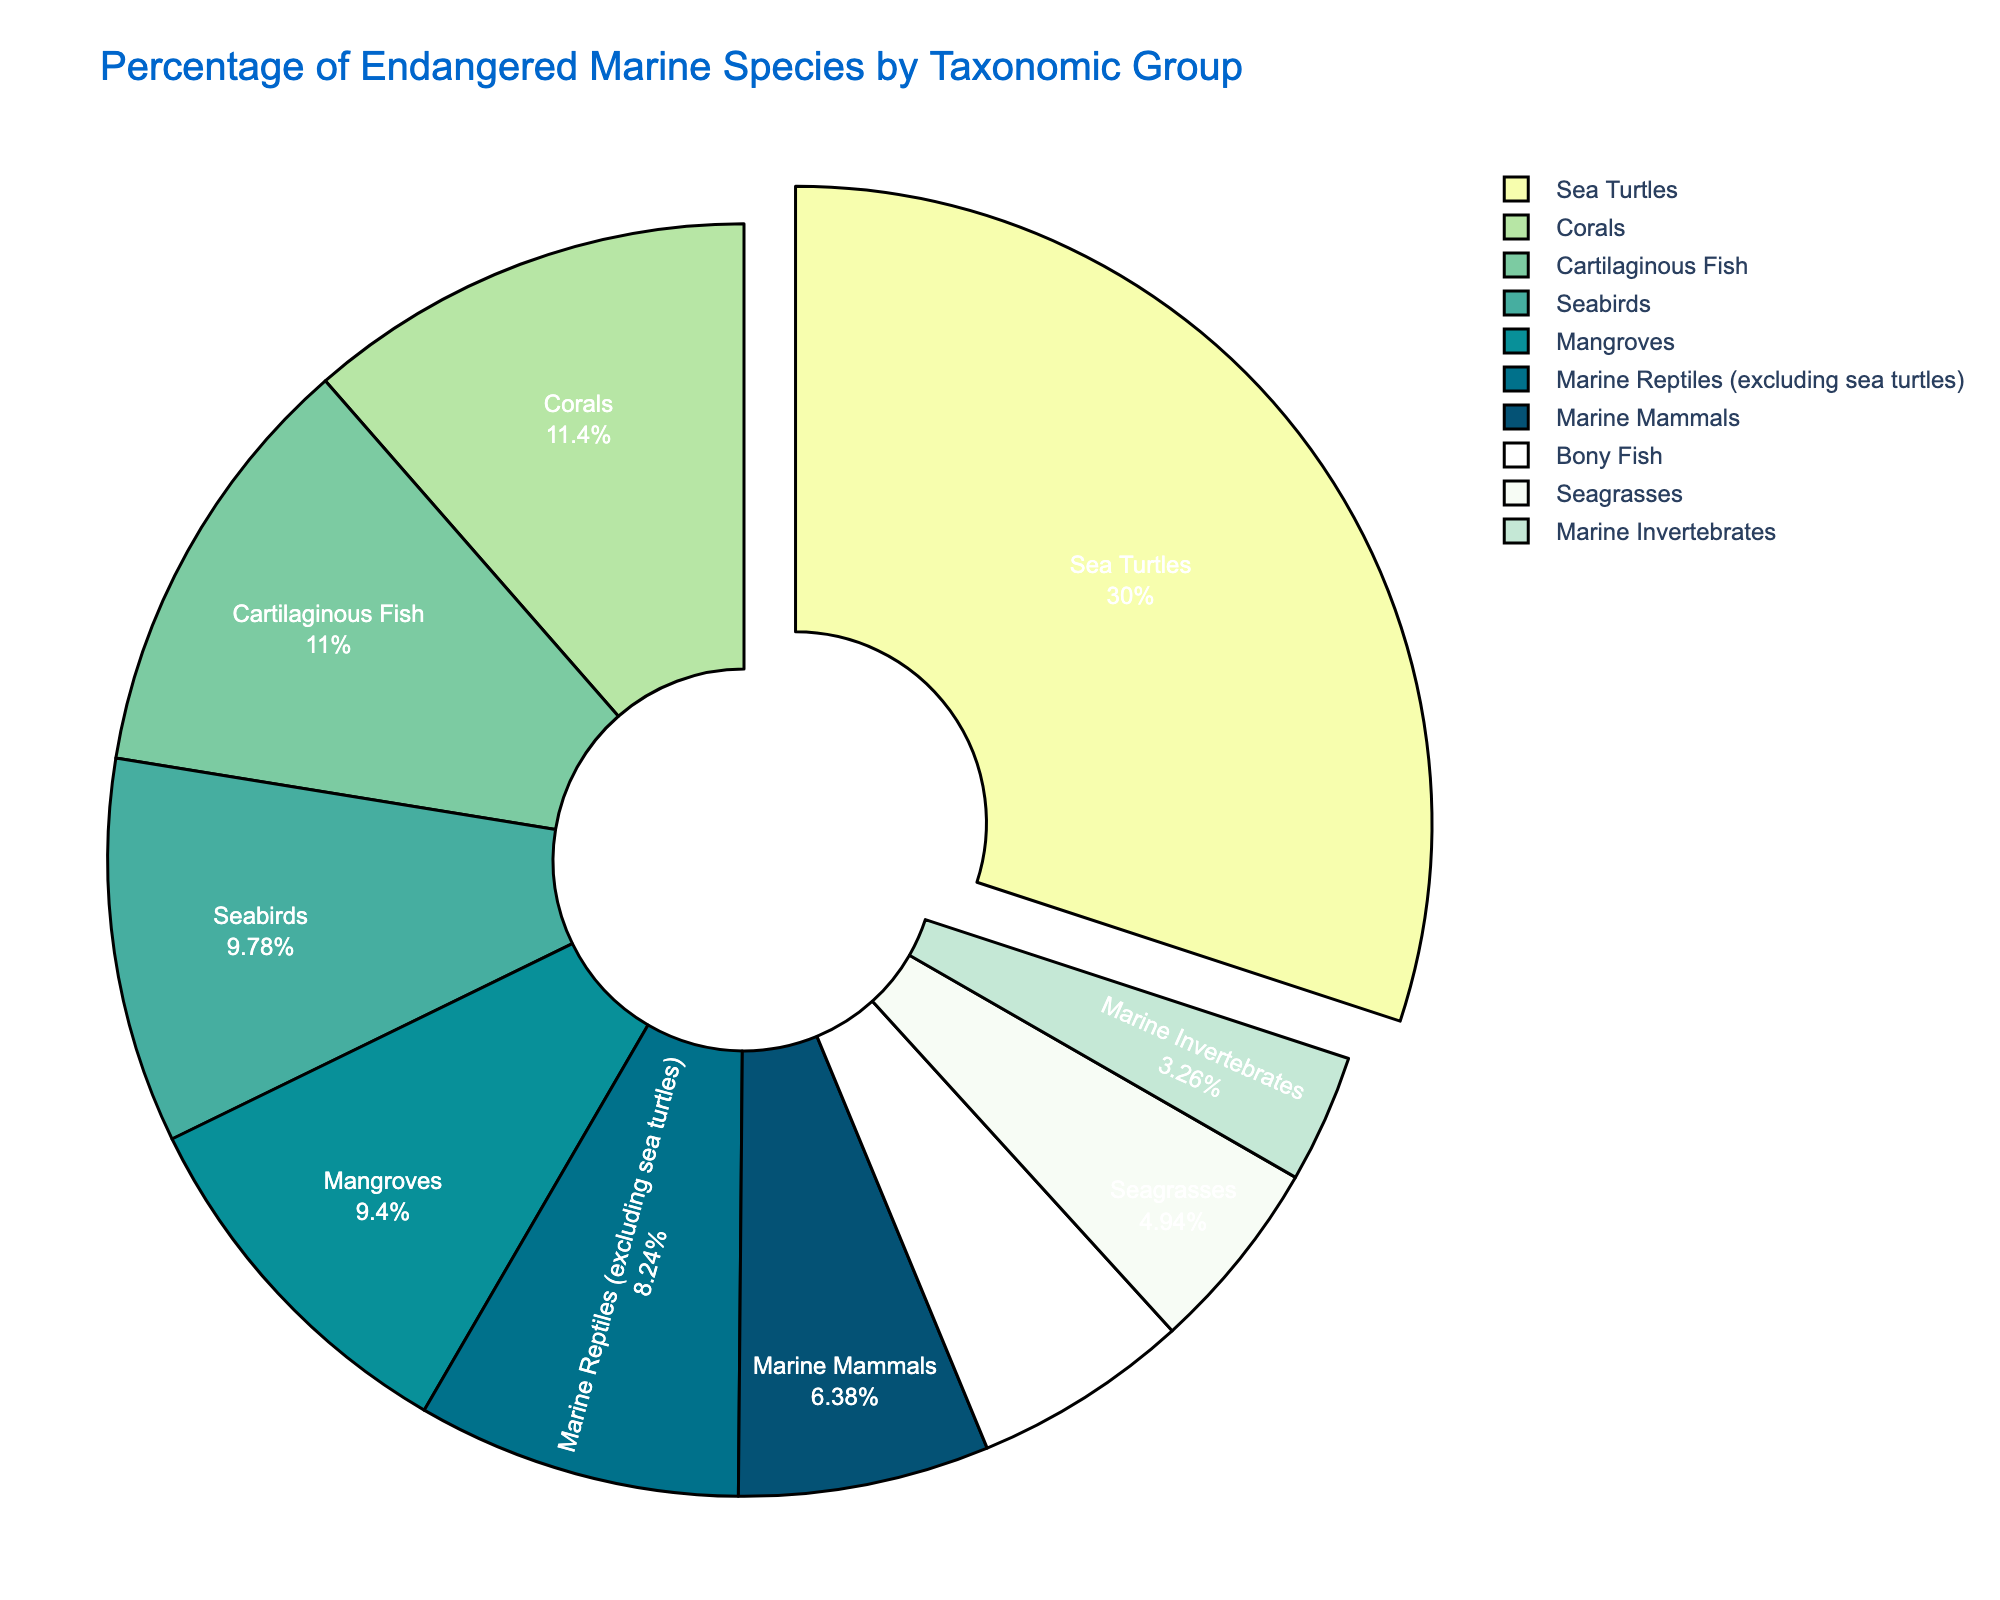What taxonomic group has the largest percentage of endangered species? To identify the taxonomic group with the largest percentage, we look for the largest slice in the pie chart. The data shows Sea Turtles with an 85.7% value, which is the highest.
Answer: Sea Turtles What is the combined percentage of endangered species in Marine Mammals and Seabirds? We find the percentage values for Marine Mammals (18.2%) and Seabirds (27.9%) from the chart and add them together: 18.2 + 27.9 = 46.1%.
Answer: 46.1% Which taxonomic group has a lower percentage of endangered species than Mangroves but higher than Marine Invertebrates? From the chart, note Mangroves have 26.8% and Marine Invertebrates have 9.3%. We identify groups between these values: Marine Reptiles (excluding sea turtles) at 23.5% and Seagrasses at 14.1%.
Answer: Seagrasses, Marine Reptiles (excluding sea turtles) How does the percentage of endangered Corals compare to the percentage of endangered Cartilaginous Fish? The chart shows Corals with 32.6% and Cartilaginous Fish with 31.4%. Compare the two values to see Corals have a slightly higher percentage.
Answer: Corals have a higher percentage What is the average percentage of endangered species across all taxonomic groups? We sum the percentages for all groups and then divide by the number of groups: (18.2 + 31.4 + 15.7 + 85.7 + 27.9 + 32.6 + 9.3 + 14.1 + 26.8 + 23.5) / 10 = 28.52%.
Answer: 28.52% Which taxonomic groups have a percentage of endangered species above 30%? By comparing each group's percentage on the chart, we find Cartilaginous Fish (31.4%), Corals (32.6%), and Sea Turtles (85.7%) exceed 30%.
Answer: Cartilaginous Fish, Corals, Sea Turtles What is the difference in percentage between the endangered Bony Fish and Marine Mammals? From the chart, Bony Fish have 15.7% and Marine Mammals 18.2%. The difference is calculated as 18.2 - 15.7 = 2.5%.
Answer: 2.5% What is the median percentage of endangered species across all taxonomic groups? Arrange the percentages in ascending order: 9.3, 14.1, 15.7, 18.2, 23.5, 26.8, 27.9, 31.4, 32.6, 85.7. Since there are 10 values, the median is the average of the 5th and 6th values: (23.5 + 26.8) / 2 = 25.15%.
Answer: 25.15% What percentage of the total endangered species do Marine Invertebrates and Seagrasses represent? Find the percentages for Marine Invertebrates (9.3%) and Seagrasses (14.1%), then add them: 9.3 + 14.1 = 23.4%.
Answer: 23.4% Which taxonomic group has an endangered species percentage closest to 25%? From the chart, the closest value to 25% is Marine Reptiles (excluding sea turtles) with 23.5%.
Answer: Marine Reptiles (excluding sea turtles) 